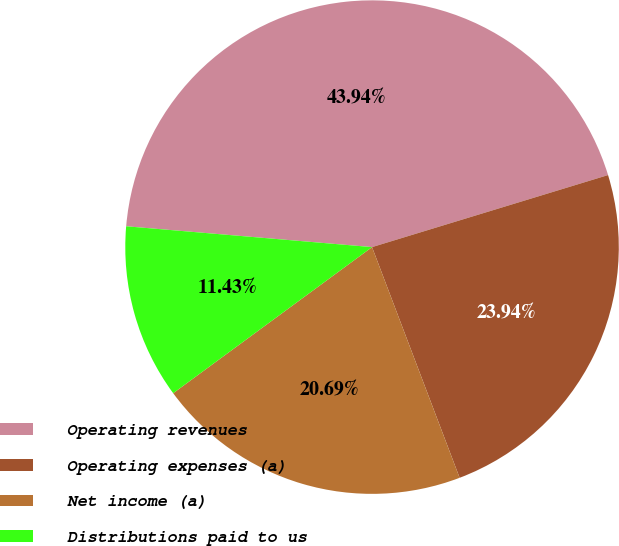Convert chart to OTSL. <chart><loc_0><loc_0><loc_500><loc_500><pie_chart><fcel>Operating revenues<fcel>Operating expenses (a)<fcel>Net income (a)<fcel>Distributions paid to us<nl><fcel>43.94%<fcel>23.94%<fcel>20.69%<fcel>11.43%<nl></chart> 